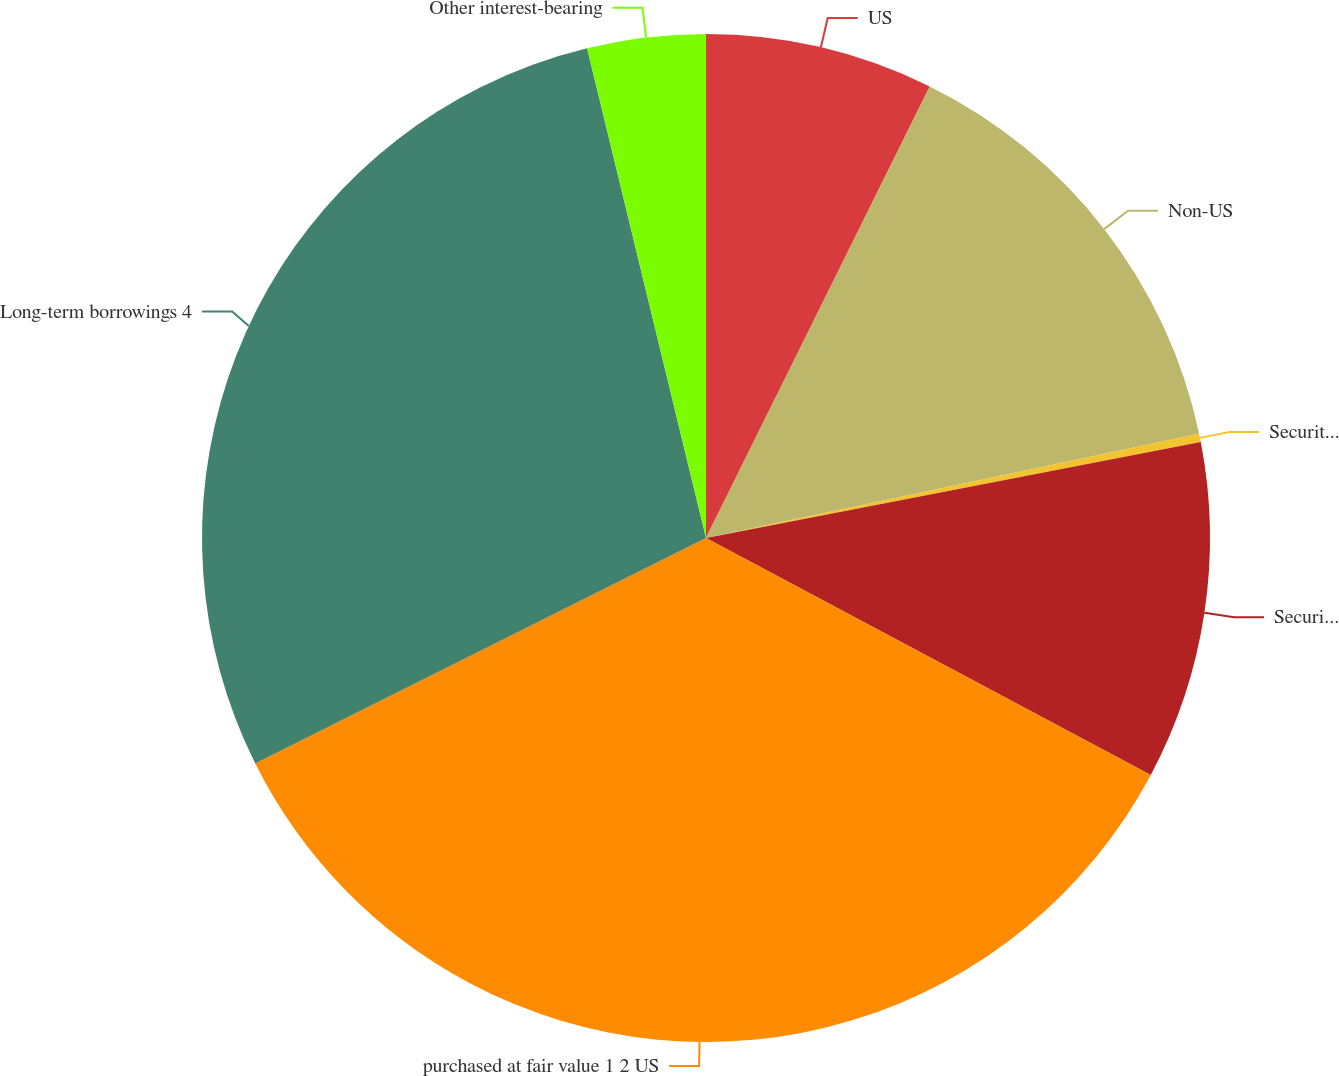Convert chart. <chart><loc_0><loc_0><loc_500><loc_500><pie_chart><fcel>US<fcel>Non-US<fcel>Securities borrowed securities<fcel>Securities loaned and<fcel>purchased at fair value 1 2 US<fcel>Long-term borrowings 4<fcel>Other interest-bearing<nl><fcel>7.32%<fcel>14.36%<fcel>0.27%<fcel>10.84%<fcel>34.82%<fcel>28.59%<fcel>3.79%<nl></chart> 